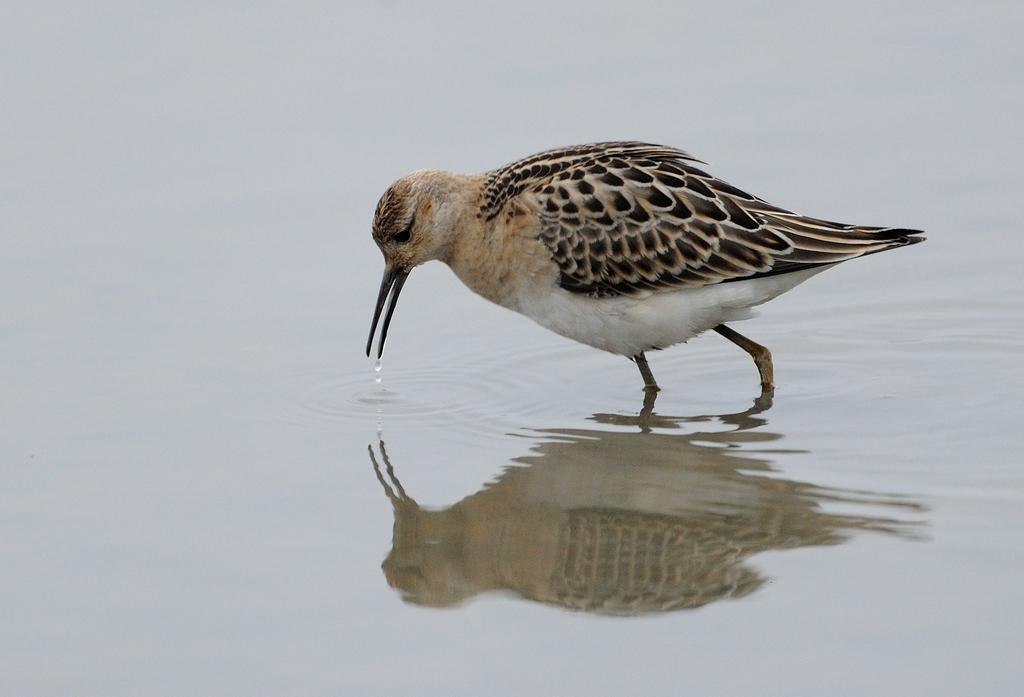Please provide a concise description of this image. This image consists of a bird drinking water. At the bottom, there is water. 